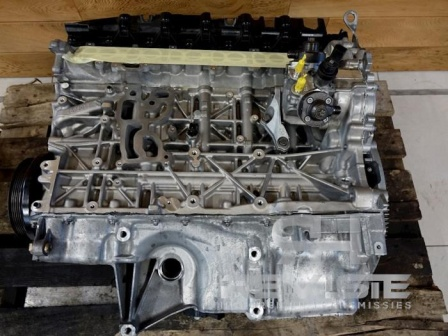Can you elaborate on the elements of the picture provided? The image showcases a meticulously detailed view of a car engine block, which is fundamental to a vehicle's operation. The engine block itself is crafted from a silver-colored metal, serving as the main structure that houses the cylinders where internal combustion occurs. 

Resting on top of the engine block is a black plastic cover, likely serving as a protective shield for the vital engine components beneath. The yellow plastic cap on the side stands out prominently, suggesting it could be a reservoir cap for essential engine fluids. 

The engine is intricately lined with several metal pipes and tubes. These components are likely integral parts of the cooling system or are involved in the fuel and air intake processes, both of which are critical to the engine's functionality. 

Currently, the engine block is placed on a wooden pallet, adding to the scene a rustic touch with its characteristic slatted design and brown hue, which contrasts sharply with the metallic silver of the engine block. 

The setting of this scene appears to be a workshop or garage environment, as indicated by the concrete floor in the background. The floor's gray, rough texture is typical in such settings due to its durability and resistance to oil and other automotive fluids. 

This image captures a moment where the engine block seems to be in transit – either awaiting installation into a vehicle or having been removed for inspection, repair, or refurbishment. 